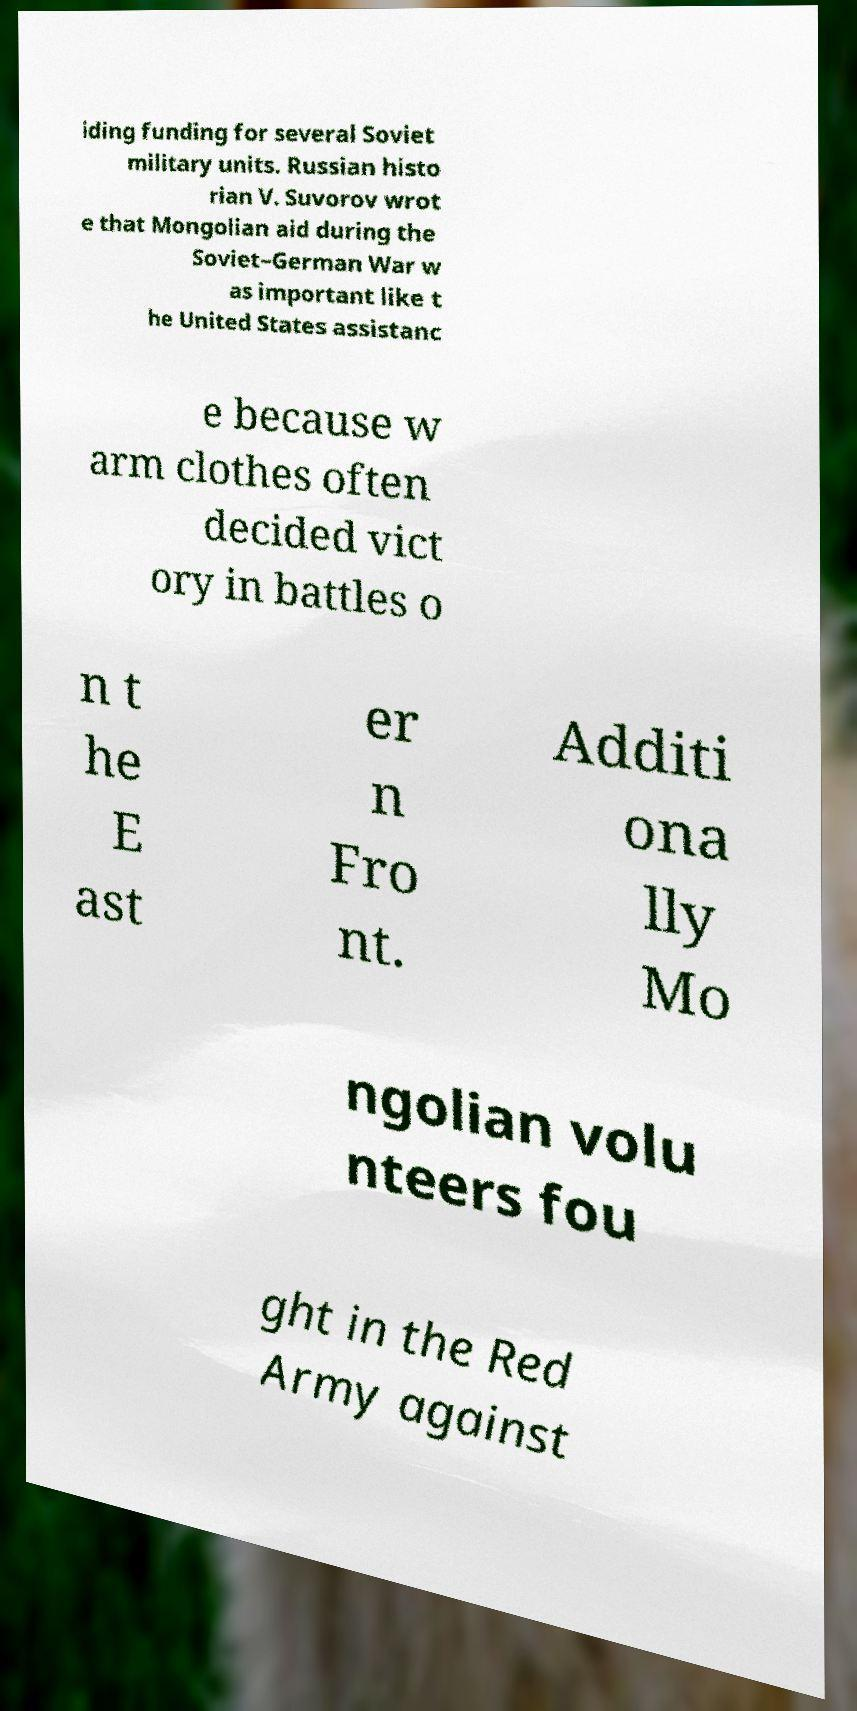Please identify and transcribe the text found in this image. iding funding for several Soviet military units. Russian histo rian V. Suvorov wrot e that Mongolian aid during the Soviet–German War w as important like t he United States assistanc e because w arm clothes often decided vict ory in battles o n t he E ast er n Fro nt. Additi ona lly Mo ngolian volu nteers fou ght in the Red Army against 